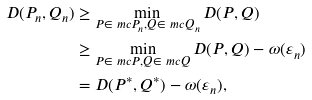<formula> <loc_0><loc_0><loc_500><loc_500>D ( P _ { n } , Q _ { n } ) & \geq \min _ { P \in \ m c { P } _ { n } , Q \in \ m c { Q } _ { n } } D ( P , Q ) \\ & \geq \min _ { P \in \ m c { P } , Q \in \ m c { Q } } D ( P , Q ) - \omega ( \varepsilon _ { n } ) \\ & = D ( P ^ { * } , Q ^ { * } ) - \omega ( \varepsilon _ { n } ) ,</formula> 